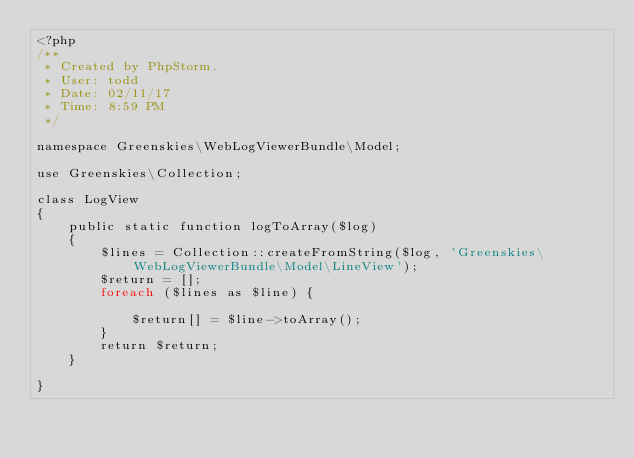<code> <loc_0><loc_0><loc_500><loc_500><_PHP_><?php
/**
 * Created by PhpStorm.
 * User: todd
 * Date: 02/11/17
 * Time: 8:59 PM
 */

namespace Greenskies\WebLogViewerBundle\Model;

use Greenskies\Collection;

class LogView
{
    public static function logToArray($log)
    {
        $lines = Collection::createFromString($log, 'Greenskies\WebLogViewerBundle\Model\LineView');
        $return = [];
        foreach ($lines as $line) {

            $return[] = $line->toArray();
        }
        return $return;
    }

}
</code> 